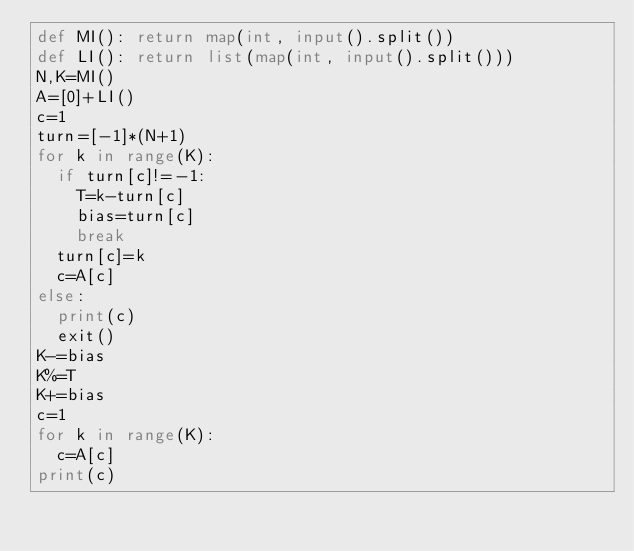Convert code to text. <code><loc_0><loc_0><loc_500><loc_500><_Python_>def MI(): return map(int, input().split())
def LI(): return list(map(int, input().split()))
N,K=MI()
A=[0]+LI()
c=1
turn=[-1]*(N+1)
for k in range(K):
  if turn[c]!=-1:
    T=k-turn[c]
    bias=turn[c]
    break
  turn[c]=k
  c=A[c]
else:
  print(c)
  exit()
K-=bias
K%=T
K+=bias
c=1
for k in range(K):
  c=A[c]
print(c)</code> 